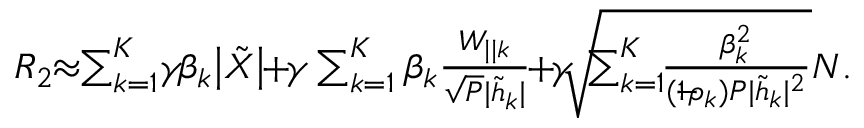<formula> <loc_0><loc_0><loc_500><loc_500>\begin{array} { r } { { { R } _ { 2 } } \, \approx \, \sum _ { k = 1 } ^ { K } \, \gamma \, \beta _ { k } \left | { { \tilde { X } } } \right | \, + \, \gamma \sum _ { k = 1 } ^ { K } \beta _ { k } \frac { { { { W } _ { | | k } } } } { \sqrt { P } { | \tilde { h } _ { k } | } } \, + \, \gamma \, \sqrt { \, \sum _ { k = 1 } ^ { K } \, \frac { \beta _ { k } ^ { 2 } } { ( 1 \, - \, \rho _ { k } ) P | \tilde { h } _ { k } | ^ { 2 } } } { N } . } \end{array}</formula> 